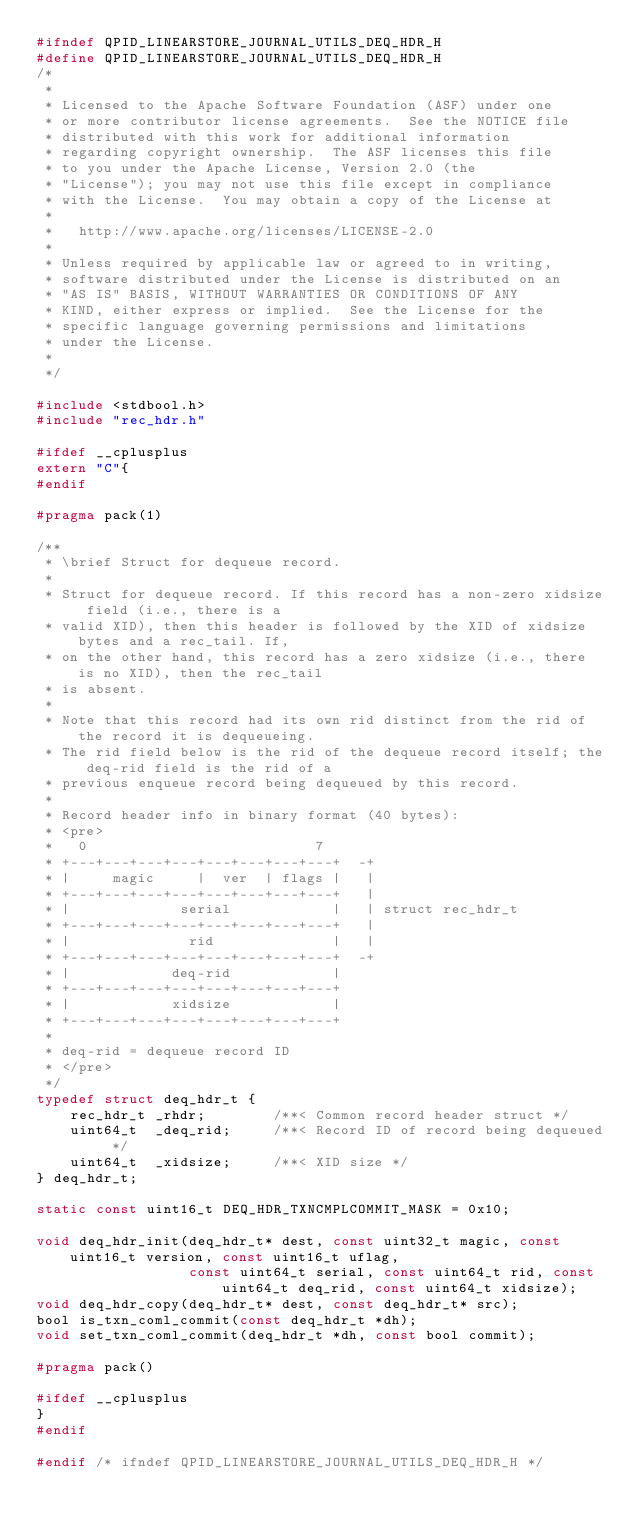<code> <loc_0><loc_0><loc_500><loc_500><_C_>#ifndef QPID_LINEARSTORE_JOURNAL_UTILS_DEQ_HDR_H
#define QPID_LINEARSTORE_JOURNAL_UTILS_DEQ_HDR_H
/*
 *
 * Licensed to the Apache Software Foundation (ASF) under one
 * or more contributor license agreements.  See the NOTICE file
 * distributed with this work for additional information
 * regarding copyright ownership.  The ASF licenses this file
 * to you under the Apache License, Version 2.0 (the
 * "License"); you may not use this file except in compliance
 * with the License.  You may obtain a copy of the License at
 *
 *   http://www.apache.org/licenses/LICENSE-2.0
 *
 * Unless required by applicable law or agreed to in writing,
 * software distributed under the License is distributed on an
 * "AS IS" BASIS, WITHOUT WARRANTIES OR CONDITIONS OF ANY
 * KIND, either express or implied.  See the License for the
 * specific language governing permissions and limitations
 * under the License.
 *
 */

#include <stdbool.h>
#include "rec_hdr.h"

#ifdef __cplusplus
extern "C"{
#endif

#pragma pack(1)

/**
 * \brief Struct for dequeue record.
 *
 * Struct for dequeue record. If this record has a non-zero xidsize field (i.e., there is a
 * valid XID), then this header is followed by the XID of xidsize bytes and a rec_tail. If,
 * on the other hand, this record has a zero xidsize (i.e., there is no XID), then the rec_tail
 * is absent.
 *
 * Note that this record had its own rid distinct from the rid of the record it is dequeueing.
 * The rid field below is the rid of the dequeue record itself; the deq-rid field is the rid of a
 * previous enqueue record being dequeued by this record.
 *
 * Record header info in binary format (40 bytes):
 * <pre>
 *   0                           7
 * +---+---+---+---+---+---+---+---+  -+
 * |     magic     |  ver  | flags |   |
 * +---+---+---+---+---+---+---+---+   |
 * |             serial            |   | struct rec_hdr_t
 * +---+---+---+---+---+---+---+---+   |
 * |              rid              |   |
 * +---+---+---+---+---+---+---+---+  -+
 * |            deq-rid            |
 * +---+---+---+---+---+---+---+---+
 * |            xidsize            |
 * +---+---+---+---+---+---+---+---+
 *
 * deq-rid = dequeue record ID
 * </pre>
 */
typedef struct deq_hdr_t {
    rec_hdr_t _rhdr;		/**< Common record header struct */
    uint64_t  _deq_rid;		/**< Record ID of record being dequeued */
    uint64_t  _xidsize;		/**< XID size */
} deq_hdr_t;

static const uint16_t DEQ_HDR_TXNCMPLCOMMIT_MASK = 0x10;

void deq_hdr_init(deq_hdr_t* dest, const uint32_t magic, const uint16_t version, const uint16_t uflag,
                  const uint64_t serial, const uint64_t rid, const uint64_t deq_rid, const uint64_t xidsize);
void deq_hdr_copy(deq_hdr_t* dest, const deq_hdr_t* src);
bool is_txn_coml_commit(const deq_hdr_t *dh);
void set_txn_coml_commit(deq_hdr_t *dh, const bool commit);

#pragma pack()

#ifdef __cplusplus
}
#endif

#endif /* ifndef QPID_LINEARSTORE_JOURNAL_UTILS_DEQ_HDR_H */
</code> 